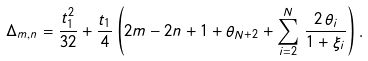<formula> <loc_0><loc_0><loc_500><loc_500>\Delta _ { m , n } = \frac { t _ { 1 } ^ { 2 } } { 3 2 } + \frac { t _ { 1 } } { 4 } \left ( 2 m - 2 n + 1 + \theta _ { N + 2 } + \sum _ { i = 2 } ^ { N } \, \frac { 2 \, \theta _ { i } } { 1 + \xi _ { i } } \right ) .</formula> 